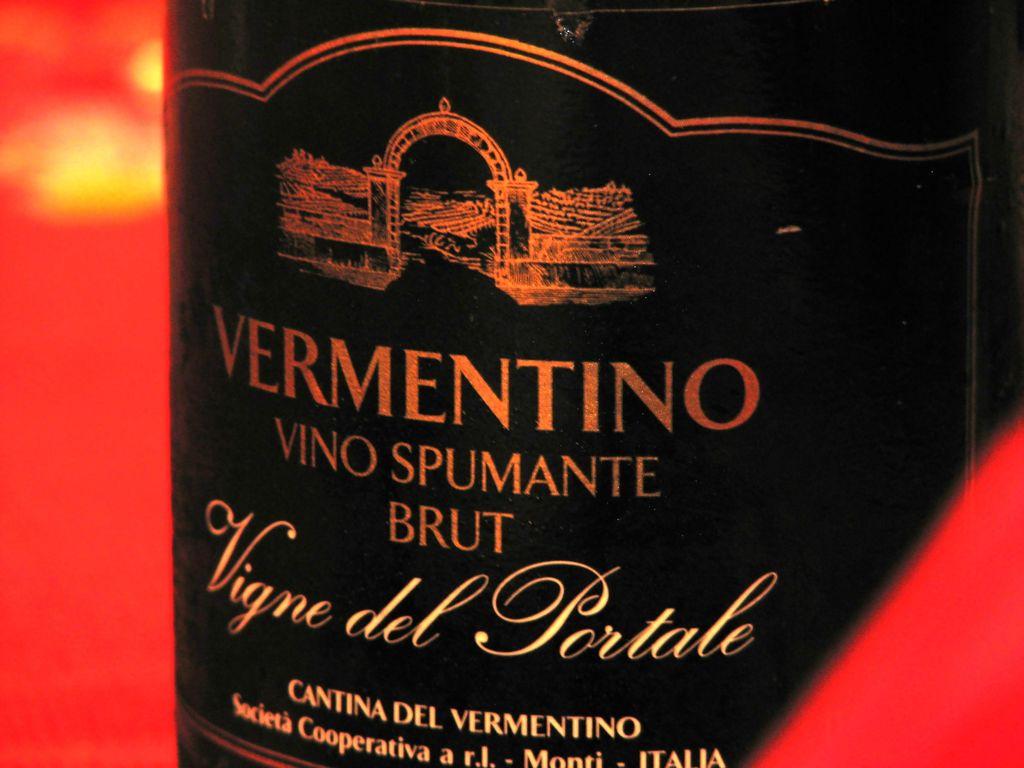What brand is this?
Provide a short and direct response. Vermentino. 